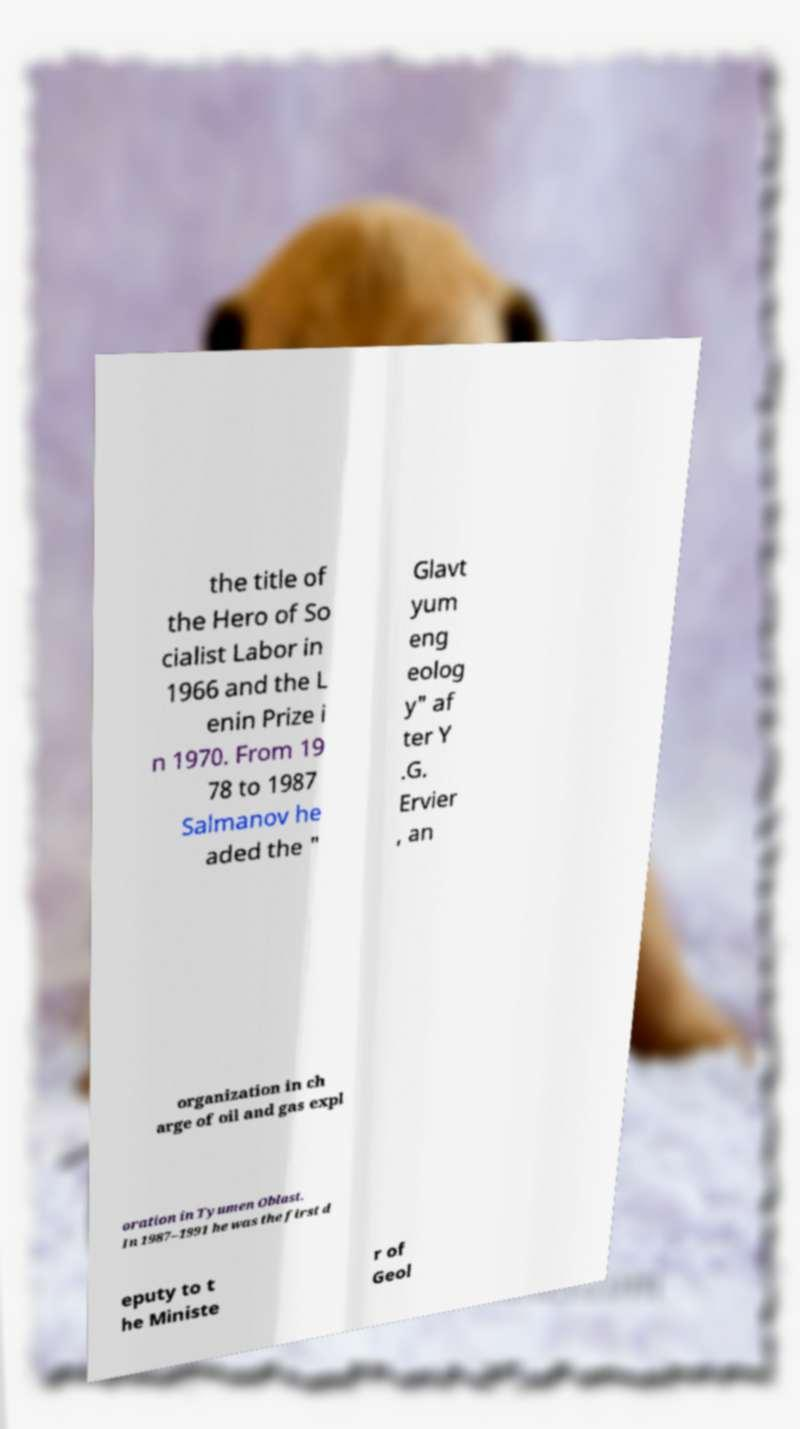Could you extract and type out the text from this image? the title of the Hero of So cialist Labor in 1966 and the L enin Prize i n 1970. From 19 78 to 1987 Salmanov he aded the " Glavt yum eng eolog y" af ter Y .G. Ervier , an organization in ch arge of oil and gas expl oration in Tyumen Oblast. In 1987–1991 he was the first d eputy to t he Ministe r of Geol 